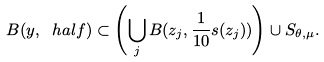<formula> <loc_0><loc_0><loc_500><loc_500>B ( y , \ h a l f ) \subset \left ( \bigcup _ { j } B ( z _ { j } , \frac { 1 } { 1 0 } s ( z _ { j } ) ) \right ) \cup S _ { \theta , \mu } .</formula> 